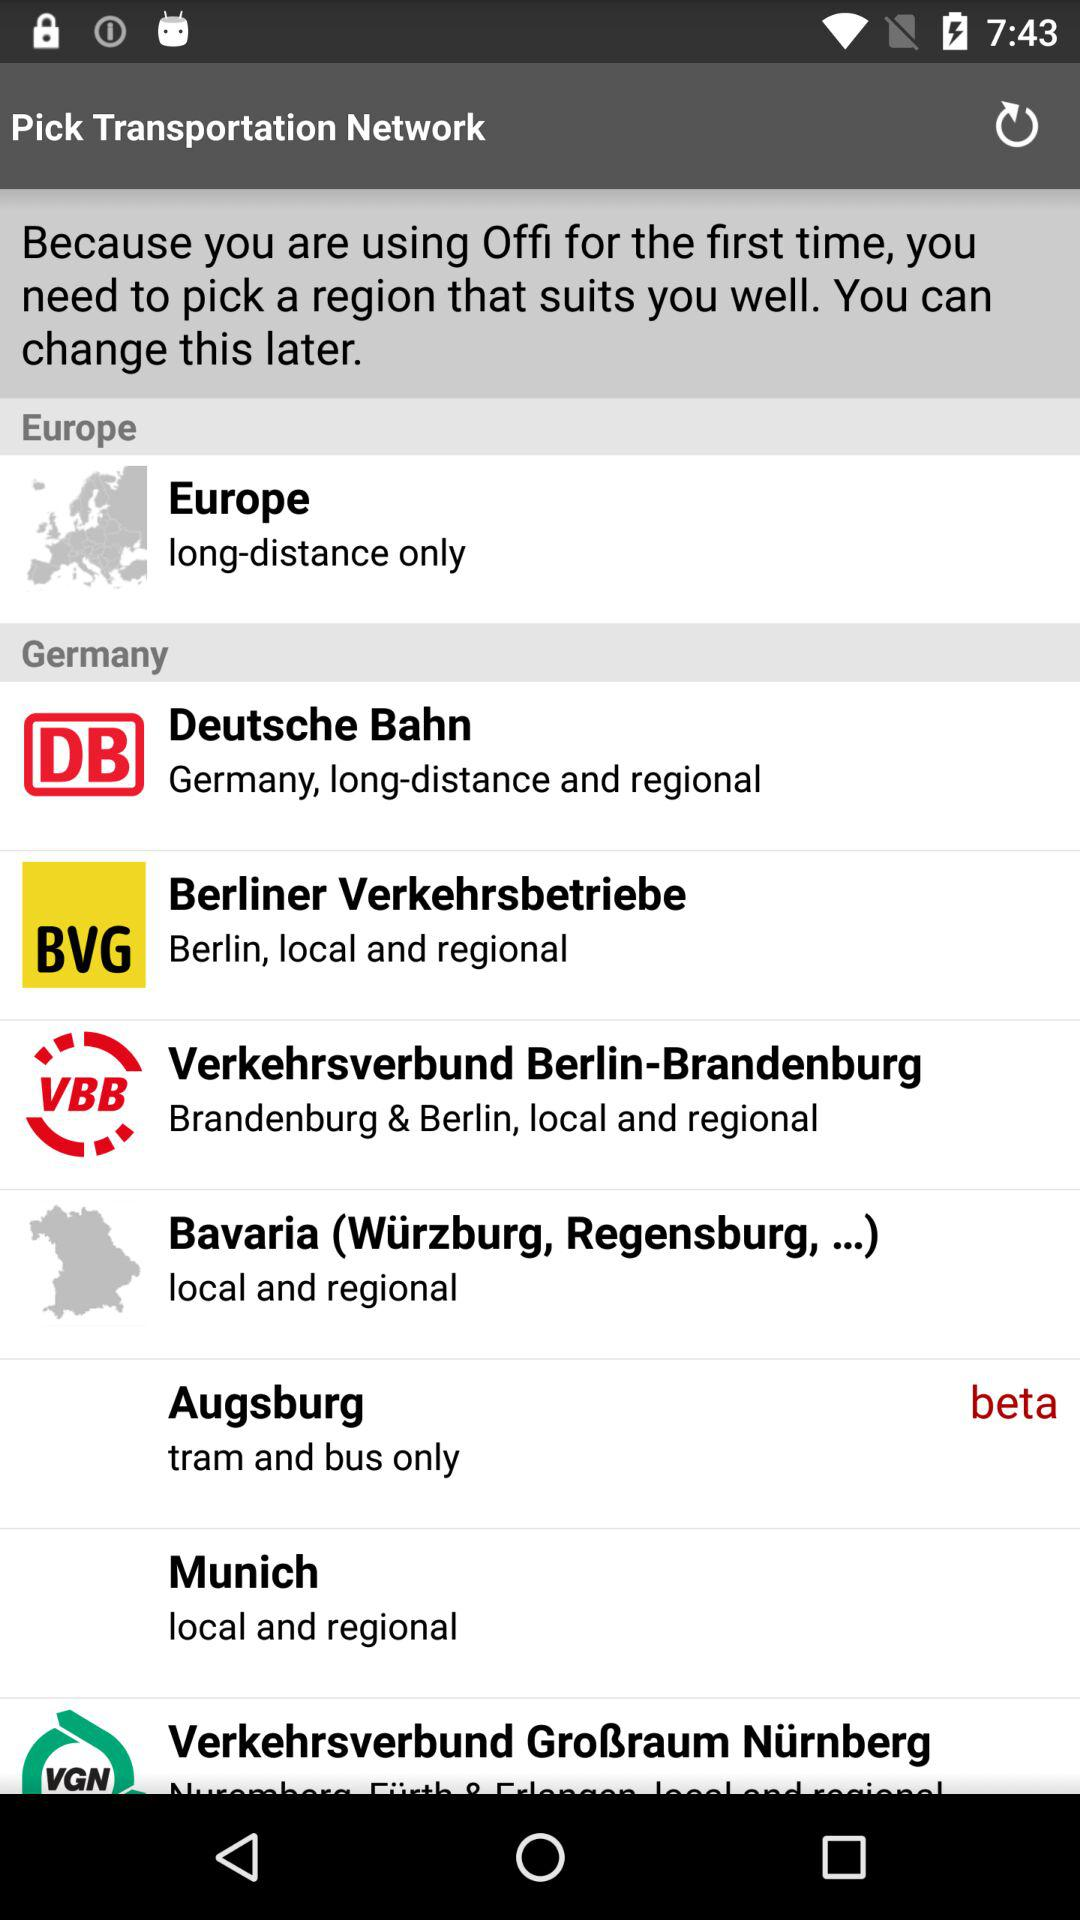Which type of distance is covered by the Deutsche Bahn transportation network? The Deutsche Bahn transportation network covers long distances. 